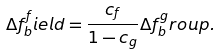<formula> <loc_0><loc_0><loc_500><loc_500>\Delta f _ { b } ^ { f } i e l d = \frac { c _ { f } } { 1 - c _ { g } } \Delta f _ { b } ^ { g } r o u p .</formula> 